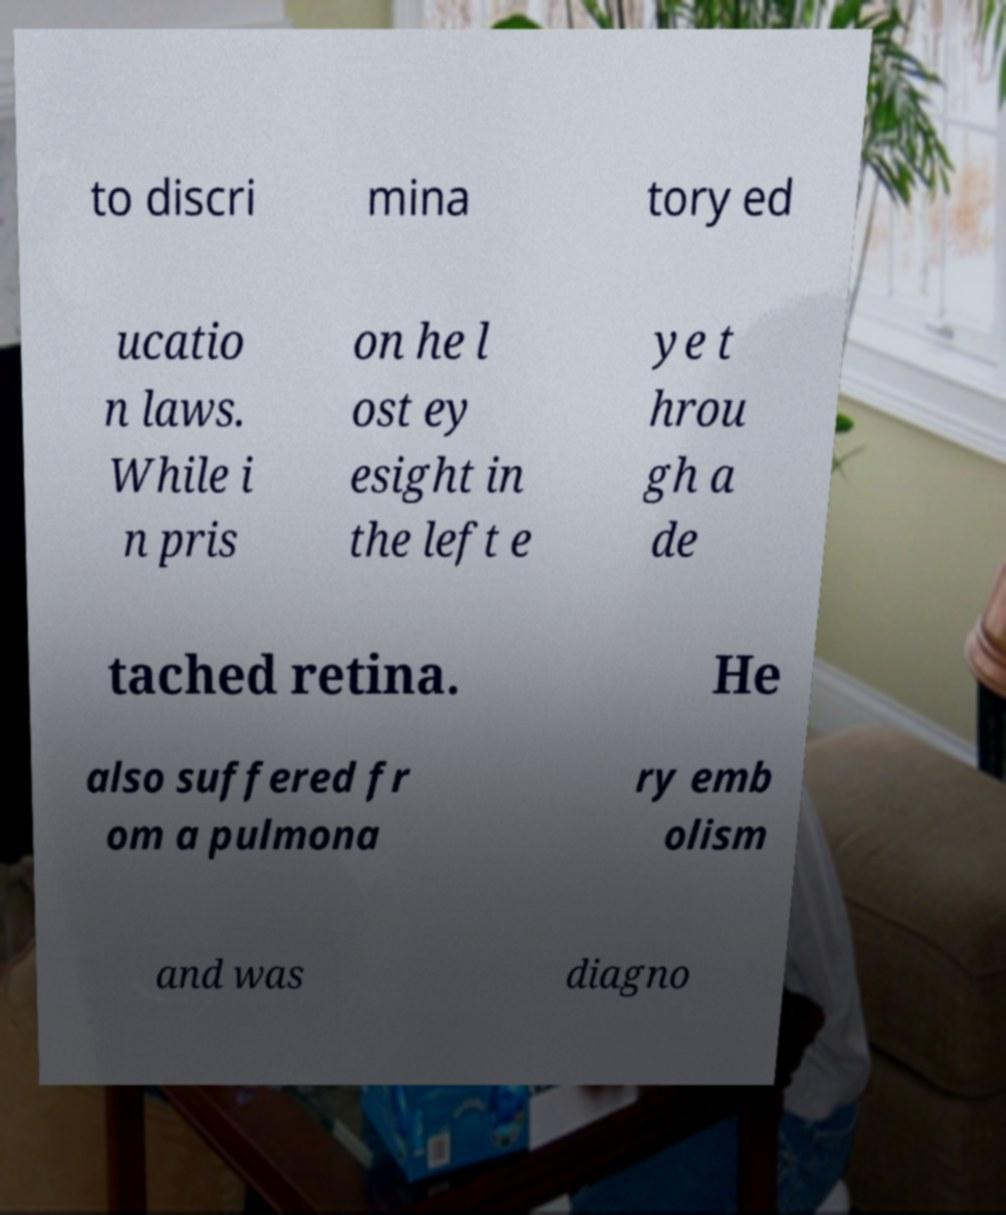I need the written content from this picture converted into text. Can you do that? to discri mina tory ed ucatio n laws. While i n pris on he l ost ey esight in the left e ye t hrou gh a de tached retina. He also suffered fr om a pulmona ry emb olism and was diagno 